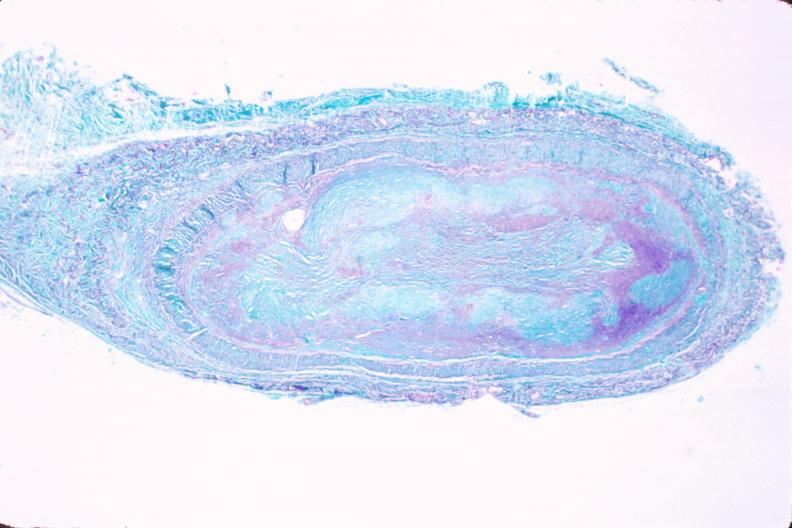does carcinomatosis show saphenous vein graft sclerosis?
Answer the question using a single word or phrase. No 